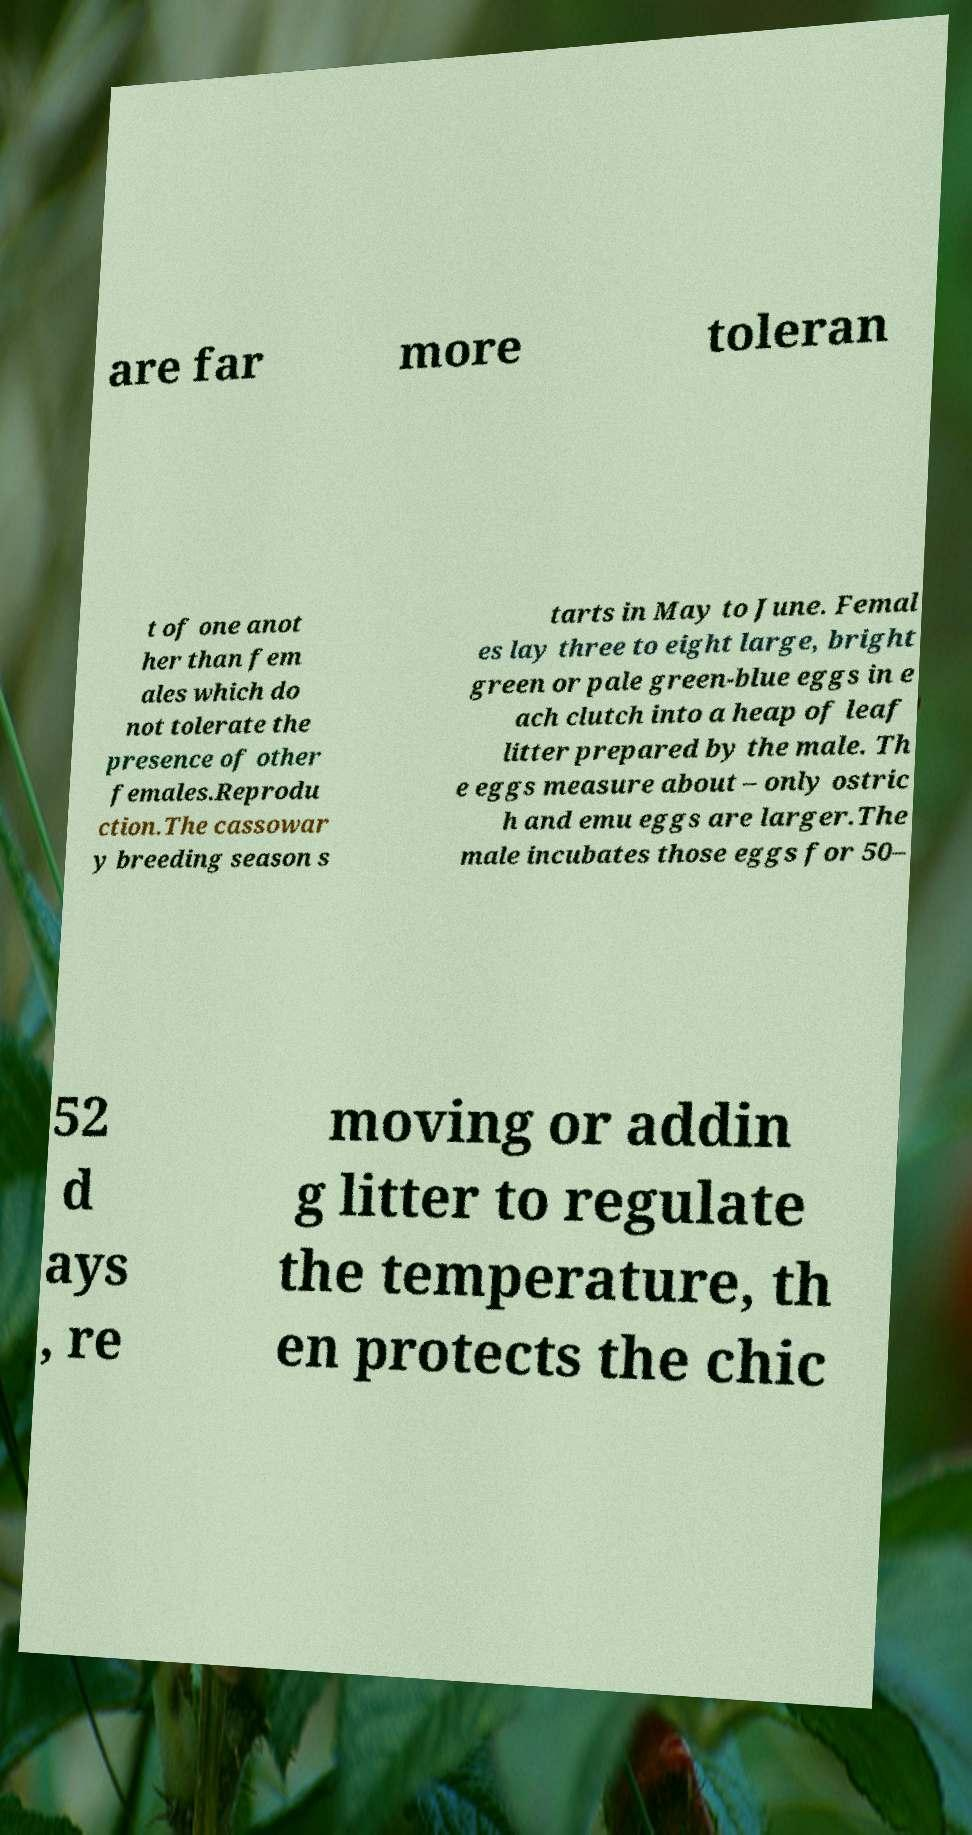Can you read and provide the text displayed in the image?This photo seems to have some interesting text. Can you extract and type it out for me? are far more toleran t of one anot her than fem ales which do not tolerate the presence of other females.Reprodu ction.The cassowar y breeding season s tarts in May to June. Femal es lay three to eight large, bright green or pale green-blue eggs in e ach clutch into a heap of leaf litter prepared by the male. Th e eggs measure about – only ostric h and emu eggs are larger.The male incubates those eggs for 50– 52 d ays , re moving or addin g litter to regulate the temperature, th en protects the chic 